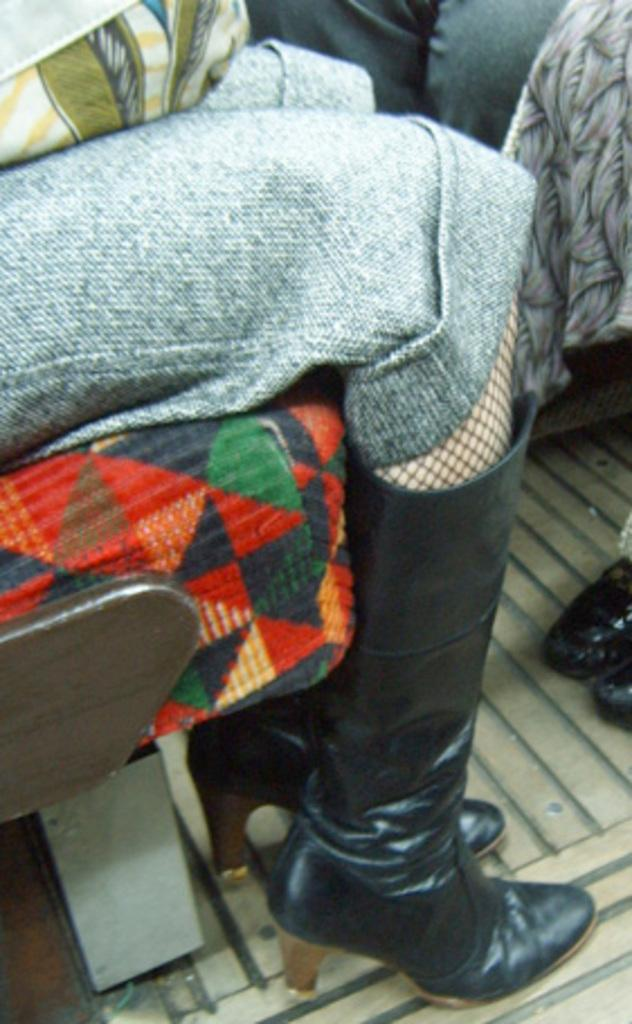What body parts are visible in the image? There are people's legs visible in the image. What type of footwear is worn by one of the people? One person is wearing black shoes. What is the position of the person wearing black shoes? The person wearing black shoes is sitting on a seat. What type of bucket is being used by the person sitting on the seat? There is no bucket present in the image. How does the person sitting on the seat affect the nerves of the other people in the image? The image does not provide information about the nerves of the people, and the person sitting on the seat is not shown to have any effect on them. 